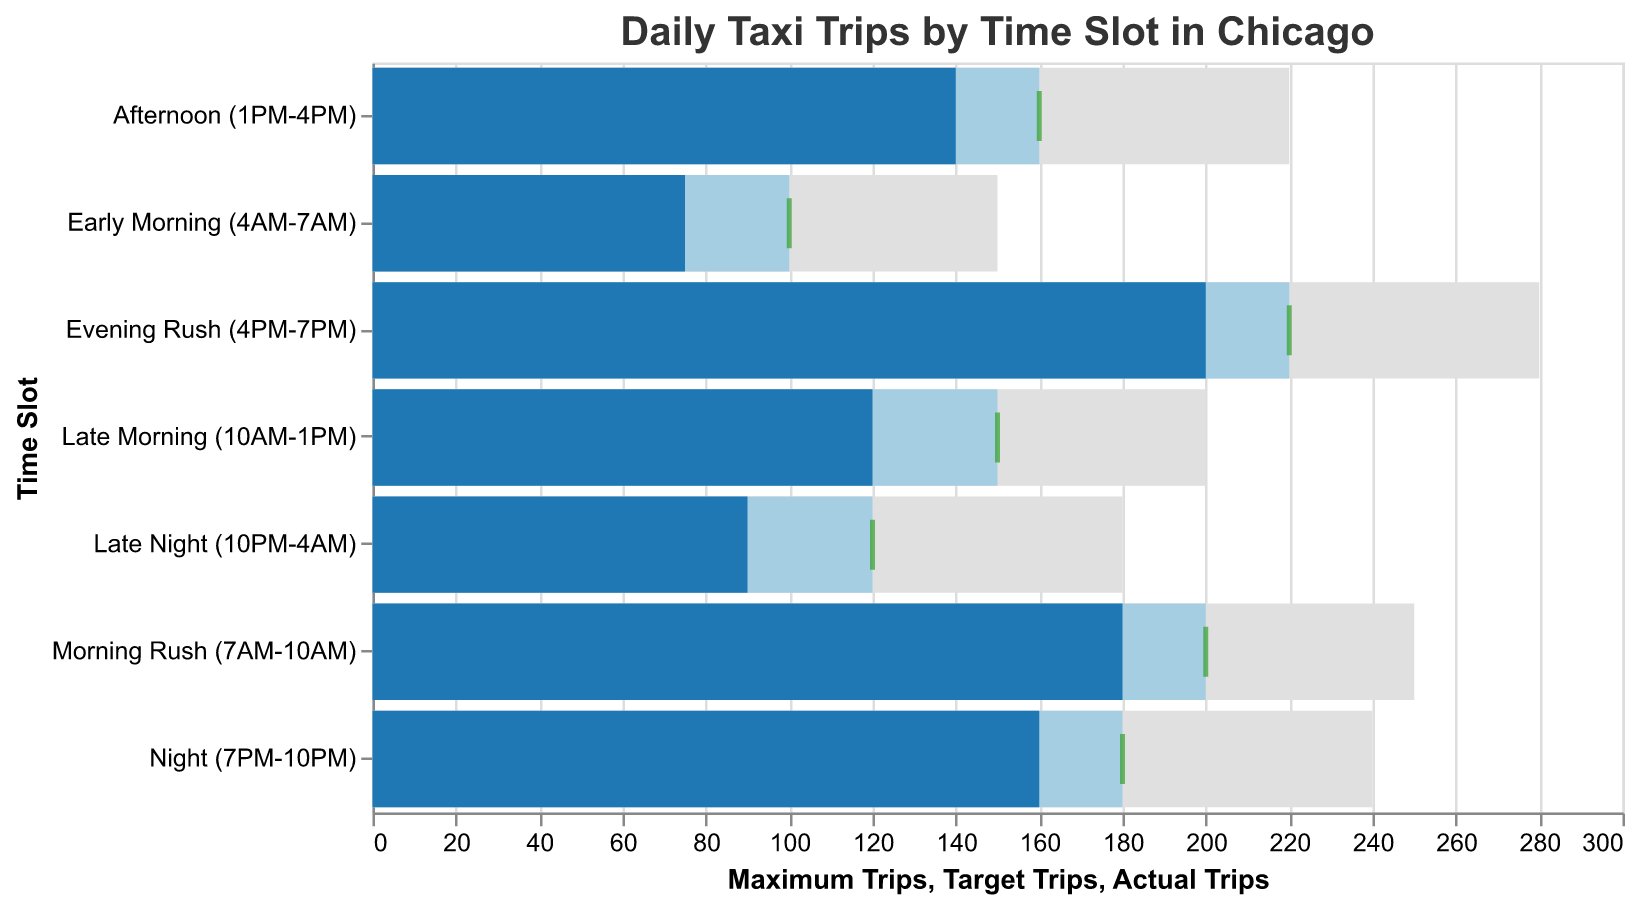What time slot has the highest number of actual trips? The "Evening Rush (4PM-7PM)" time slot shows an actual trip count of 200, which is the highest among all time slots.
Answer: Evening Rush (4PM-7PM) What is the difference between the actual trips and target trips for the Morning Rush (7AM-10AM)? The actual trips for the Morning Rush are 180, and the target trips are 200. The difference is 200 - 180 = 20.
Answer: 20 Which time slot has the smallest gap between actual trips and maximum trips? By evaluating each time slot, the "Evening Rush (4PM-7PM)" has actual trips at 200 and maximum trips at 280, a gap of 280 - 200 = 80. This is the smallest gap compared to other slots.
Answer: Evening Rush (4PM-7PM) How does the number of actual trips in the Late Night (10PM-4AM) compare to the Early Morning (4AM-7AM)? The Late Night slot has 90 actual trips, while the Early Morning slot has 75. Thus, there are 15 more actual trips in the Late Night.
Answer: 15 more What is the average number of target trips across all time slots? Adding up all the target trips (100 + 200 + 150 + 160 + 220 + 180 + 120) gives 1130. There are 7 time slots, so the average is 1130 / 7 ≈ 161.43.
Answer: 161.43 In which time slot did the actual trips fall short of the target trips the most? Subtracting actual trips from target trips for all slots: 
- Early Morning: 100 - 75 = 25
- Morning Rush: 200 - 180 = 20
- Late Morning: 150 - 120 = 30
- Afternoon: 160 - 140 = 20
- Evening Rush: 220 - 200 = 20
- Night: 180 - 160 = 20
- Late Night: 120 - 90 = 30
Both "Late Morning (10AM-1PM)" and "Late Night (10PM-4AM)" have the largest shortfall of 30 trips.
Answer: Late Morning (10AM-1PM) and Late Night (10PM-4AM) What proportion of the maximum trips were achieved in the Afternoon (1PM-4PM) slot? The actual trips in the Afternoon slot are 140, and the maximum trips are 220. The proportion is 140 / 220 = 0.636, or 63.6%.
Answer: 63.6% Which time slot is closest to meeting its target trips? Calculating the ratio of actual to target trips for each time slot:
- Early Morning: 75 / 100 = 0.75
- Morning Rush: 180 / 200 = 0.90
- Late Morning: 120 / 150 = 0.80
- Afternoon: 140 / 160 = 0.875
- Evening Rush: 200 / 220 = 0.909
- Night: 160 / 180 = 0.889
- Late Night: 90 / 120 = 0.75
The "Evening Rush (4PM-7PM)" slot has the highest ratio, closest to 1, at 0.909.
Answer: Evening Rush (4PM-7PM) What is the total number of actual trips across all time slots? Summing up the actual trips across all slots (75 + 180 + 120 + 140 + 200 + 160 + 90) gives 965.
Answer: 965 